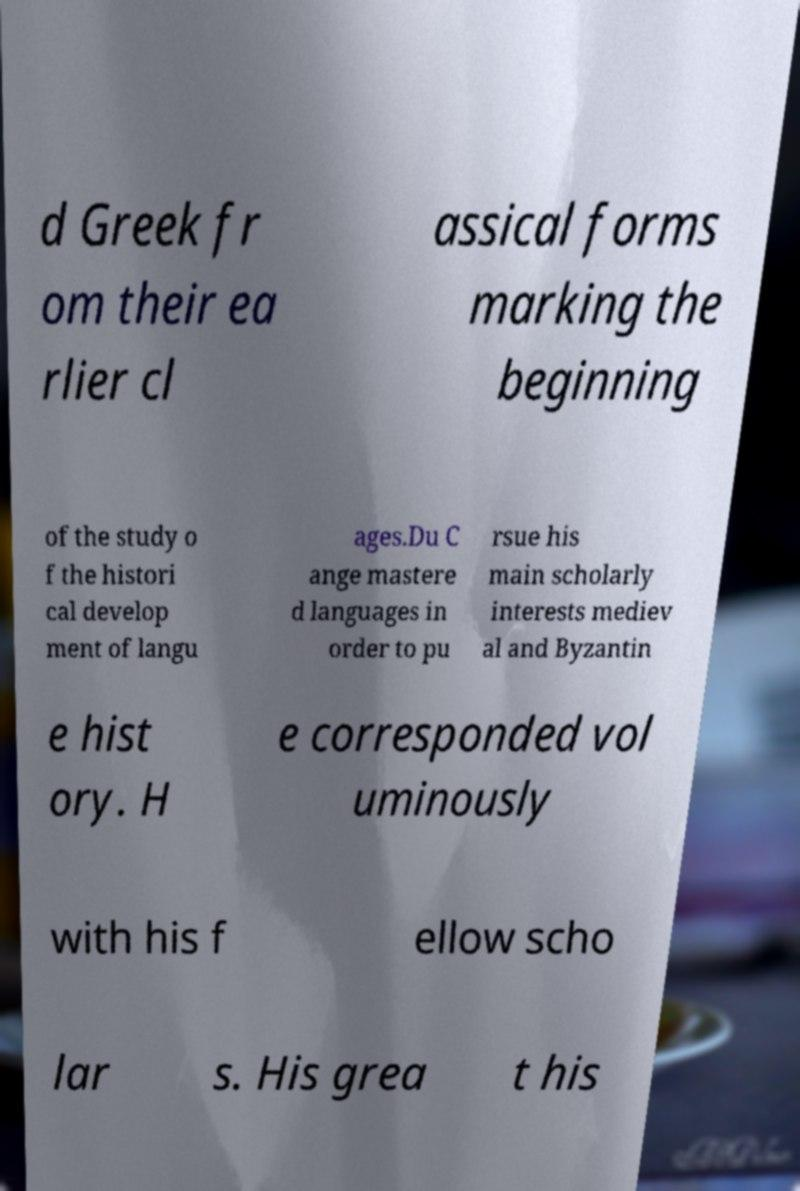Please read and relay the text visible in this image. What does it say? d Greek fr om their ea rlier cl assical forms marking the beginning of the study o f the histori cal develop ment of langu ages.Du C ange mastere d languages in order to pu rsue his main scholarly interests mediev al and Byzantin e hist ory. H e corresponded vol uminously with his f ellow scho lar s. His grea t his 